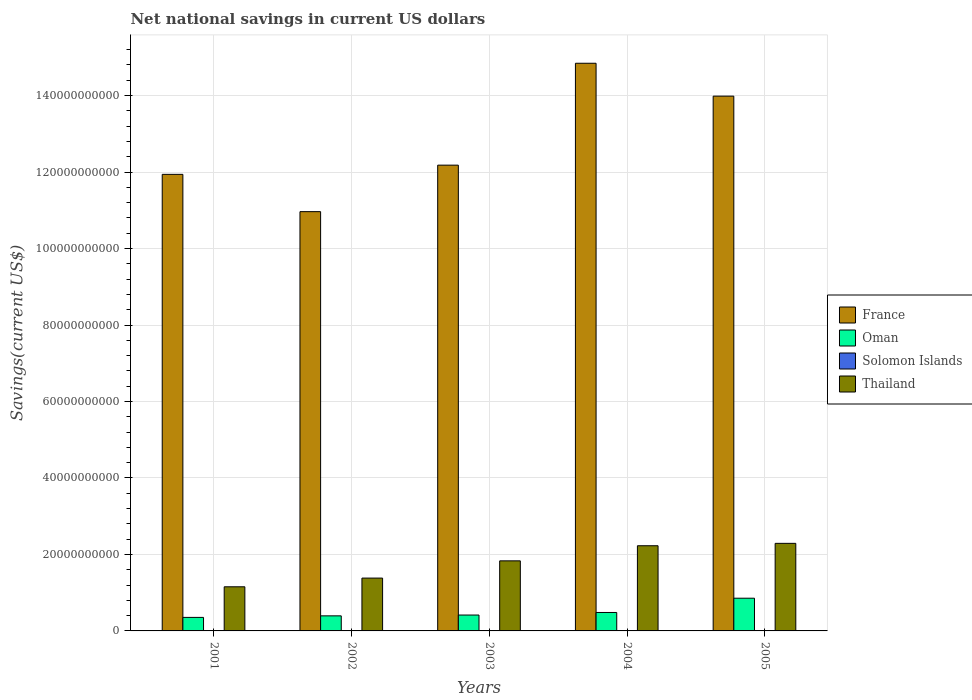How many groups of bars are there?
Make the answer very short. 5. How many bars are there on the 2nd tick from the left?
Give a very brief answer. 3. What is the net national savings in Thailand in 2002?
Ensure brevity in your answer.  1.38e+1. Across all years, what is the maximum net national savings in France?
Provide a succinct answer. 1.48e+11. What is the total net national savings in Oman in the graph?
Provide a short and direct response. 2.50e+1. What is the difference between the net national savings in France in 2003 and that in 2005?
Ensure brevity in your answer.  -1.80e+1. What is the difference between the net national savings in France in 2003 and the net national savings in Solomon Islands in 2001?
Provide a short and direct response. 1.22e+11. What is the average net national savings in Solomon Islands per year?
Ensure brevity in your answer.  2.64e+06. In the year 2003, what is the difference between the net national savings in Thailand and net national savings in Oman?
Offer a very short reply. 1.42e+1. What is the ratio of the net national savings in France in 2003 to that in 2005?
Keep it short and to the point. 0.87. Is the net national savings in Oman in 2003 less than that in 2004?
Make the answer very short. Yes. Is the difference between the net national savings in Thailand in 2002 and 2005 greater than the difference between the net national savings in Oman in 2002 and 2005?
Offer a terse response. No. What is the difference between the highest and the second highest net national savings in Oman?
Give a very brief answer. 3.73e+09. What is the difference between the highest and the lowest net national savings in France?
Provide a succinct answer. 3.88e+1. In how many years, is the net national savings in Solomon Islands greater than the average net national savings in Solomon Islands taken over all years?
Keep it short and to the point. 1. Is it the case that in every year, the sum of the net national savings in Thailand and net national savings in France is greater than the sum of net national savings in Oman and net national savings in Solomon Islands?
Keep it short and to the point. Yes. Is it the case that in every year, the sum of the net national savings in Oman and net national savings in Thailand is greater than the net national savings in France?
Ensure brevity in your answer.  No. How many bars are there?
Give a very brief answer. 16. Are all the bars in the graph horizontal?
Make the answer very short. No. How many years are there in the graph?
Offer a terse response. 5. What is the difference between two consecutive major ticks on the Y-axis?
Offer a terse response. 2.00e+1. Are the values on the major ticks of Y-axis written in scientific E-notation?
Your response must be concise. No. Does the graph contain any zero values?
Your response must be concise. Yes. Does the graph contain grids?
Keep it short and to the point. Yes. How are the legend labels stacked?
Your answer should be very brief. Vertical. What is the title of the graph?
Provide a succinct answer. Net national savings in current US dollars. Does "Vanuatu" appear as one of the legend labels in the graph?
Your response must be concise. No. What is the label or title of the X-axis?
Make the answer very short. Years. What is the label or title of the Y-axis?
Your answer should be very brief. Savings(current US$). What is the Savings(current US$) in France in 2001?
Ensure brevity in your answer.  1.19e+11. What is the Savings(current US$) of Oman in 2001?
Your answer should be very brief. 3.54e+09. What is the Savings(current US$) in Thailand in 2001?
Provide a succinct answer. 1.15e+1. What is the Savings(current US$) in France in 2002?
Give a very brief answer. 1.10e+11. What is the Savings(current US$) of Oman in 2002?
Your answer should be compact. 3.94e+09. What is the Savings(current US$) of Solomon Islands in 2002?
Give a very brief answer. 0. What is the Savings(current US$) in Thailand in 2002?
Ensure brevity in your answer.  1.38e+1. What is the Savings(current US$) of France in 2003?
Offer a terse response. 1.22e+11. What is the Savings(current US$) in Oman in 2003?
Offer a very short reply. 4.15e+09. What is the Savings(current US$) of Solomon Islands in 2003?
Provide a short and direct response. 1.32e+07. What is the Savings(current US$) in Thailand in 2003?
Your answer should be very brief. 1.83e+1. What is the Savings(current US$) in France in 2004?
Your answer should be compact. 1.48e+11. What is the Savings(current US$) in Oman in 2004?
Ensure brevity in your answer.  4.82e+09. What is the Savings(current US$) in Solomon Islands in 2004?
Ensure brevity in your answer.  0. What is the Savings(current US$) of Thailand in 2004?
Ensure brevity in your answer.  2.23e+1. What is the Savings(current US$) of France in 2005?
Provide a short and direct response. 1.40e+11. What is the Savings(current US$) of Oman in 2005?
Keep it short and to the point. 8.55e+09. What is the Savings(current US$) in Solomon Islands in 2005?
Your answer should be very brief. 0. What is the Savings(current US$) of Thailand in 2005?
Give a very brief answer. 2.29e+1. Across all years, what is the maximum Savings(current US$) of France?
Your response must be concise. 1.48e+11. Across all years, what is the maximum Savings(current US$) in Oman?
Your answer should be compact. 8.55e+09. Across all years, what is the maximum Savings(current US$) in Solomon Islands?
Give a very brief answer. 1.32e+07. Across all years, what is the maximum Savings(current US$) in Thailand?
Make the answer very short. 2.29e+1. Across all years, what is the minimum Savings(current US$) of France?
Offer a very short reply. 1.10e+11. Across all years, what is the minimum Savings(current US$) of Oman?
Keep it short and to the point. 3.54e+09. Across all years, what is the minimum Savings(current US$) of Thailand?
Your response must be concise. 1.15e+1. What is the total Savings(current US$) of France in the graph?
Your answer should be very brief. 6.39e+11. What is the total Savings(current US$) in Oman in the graph?
Your answer should be very brief. 2.50e+1. What is the total Savings(current US$) of Solomon Islands in the graph?
Your answer should be very brief. 1.32e+07. What is the total Savings(current US$) in Thailand in the graph?
Provide a short and direct response. 8.89e+1. What is the difference between the Savings(current US$) in France in 2001 and that in 2002?
Your answer should be very brief. 9.76e+09. What is the difference between the Savings(current US$) of Oman in 2001 and that in 2002?
Keep it short and to the point. -4.06e+08. What is the difference between the Savings(current US$) in Thailand in 2001 and that in 2002?
Offer a very short reply. -2.28e+09. What is the difference between the Savings(current US$) in France in 2001 and that in 2003?
Offer a very short reply. -2.41e+09. What is the difference between the Savings(current US$) of Oman in 2001 and that in 2003?
Give a very brief answer. -6.16e+08. What is the difference between the Savings(current US$) in Thailand in 2001 and that in 2003?
Your answer should be very brief. -6.78e+09. What is the difference between the Savings(current US$) of France in 2001 and that in 2004?
Your response must be concise. -2.91e+1. What is the difference between the Savings(current US$) of Oman in 2001 and that in 2004?
Give a very brief answer. -1.29e+09. What is the difference between the Savings(current US$) in Thailand in 2001 and that in 2004?
Give a very brief answer. -1.07e+1. What is the difference between the Savings(current US$) of France in 2001 and that in 2005?
Make the answer very short. -2.05e+1. What is the difference between the Savings(current US$) in Oman in 2001 and that in 2005?
Keep it short and to the point. -5.02e+09. What is the difference between the Savings(current US$) of Thailand in 2001 and that in 2005?
Offer a terse response. -1.14e+1. What is the difference between the Savings(current US$) of France in 2002 and that in 2003?
Your response must be concise. -1.22e+1. What is the difference between the Savings(current US$) in Oman in 2002 and that in 2003?
Your answer should be compact. -2.10e+08. What is the difference between the Savings(current US$) of Thailand in 2002 and that in 2003?
Provide a succinct answer. -4.50e+09. What is the difference between the Savings(current US$) in France in 2002 and that in 2004?
Offer a very short reply. -3.88e+1. What is the difference between the Savings(current US$) in Oman in 2002 and that in 2004?
Offer a very short reply. -8.83e+08. What is the difference between the Savings(current US$) in Thailand in 2002 and that in 2004?
Give a very brief answer. -8.46e+09. What is the difference between the Savings(current US$) of France in 2002 and that in 2005?
Give a very brief answer. -3.02e+1. What is the difference between the Savings(current US$) in Oman in 2002 and that in 2005?
Make the answer very short. -4.61e+09. What is the difference between the Savings(current US$) in Thailand in 2002 and that in 2005?
Give a very brief answer. -9.08e+09. What is the difference between the Savings(current US$) of France in 2003 and that in 2004?
Your answer should be very brief. -2.66e+1. What is the difference between the Savings(current US$) in Oman in 2003 and that in 2004?
Offer a terse response. -6.73e+08. What is the difference between the Savings(current US$) in Thailand in 2003 and that in 2004?
Provide a short and direct response. -3.95e+09. What is the difference between the Savings(current US$) of France in 2003 and that in 2005?
Give a very brief answer. -1.80e+1. What is the difference between the Savings(current US$) in Oman in 2003 and that in 2005?
Offer a very short reply. -4.40e+09. What is the difference between the Savings(current US$) of Thailand in 2003 and that in 2005?
Your answer should be very brief. -4.58e+09. What is the difference between the Savings(current US$) of France in 2004 and that in 2005?
Your answer should be compact. 8.60e+09. What is the difference between the Savings(current US$) in Oman in 2004 and that in 2005?
Your answer should be compact. -3.73e+09. What is the difference between the Savings(current US$) in Thailand in 2004 and that in 2005?
Offer a very short reply. -6.24e+08. What is the difference between the Savings(current US$) in France in 2001 and the Savings(current US$) in Oman in 2002?
Provide a short and direct response. 1.15e+11. What is the difference between the Savings(current US$) in France in 2001 and the Savings(current US$) in Thailand in 2002?
Give a very brief answer. 1.06e+11. What is the difference between the Savings(current US$) of Oman in 2001 and the Savings(current US$) of Thailand in 2002?
Ensure brevity in your answer.  -1.03e+1. What is the difference between the Savings(current US$) of France in 2001 and the Savings(current US$) of Oman in 2003?
Your answer should be very brief. 1.15e+11. What is the difference between the Savings(current US$) in France in 2001 and the Savings(current US$) in Solomon Islands in 2003?
Offer a very short reply. 1.19e+11. What is the difference between the Savings(current US$) of France in 2001 and the Savings(current US$) of Thailand in 2003?
Keep it short and to the point. 1.01e+11. What is the difference between the Savings(current US$) in Oman in 2001 and the Savings(current US$) in Solomon Islands in 2003?
Your answer should be very brief. 3.52e+09. What is the difference between the Savings(current US$) in Oman in 2001 and the Savings(current US$) in Thailand in 2003?
Provide a succinct answer. -1.48e+1. What is the difference between the Savings(current US$) in France in 2001 and the Savings(current US$) in Oman in 2004?
Offer a terse response. 1.15e+11. What is the difference between the Savings(current US$) of France in 2001 and the Savings(current US$) of Thailand in 2004?
Provide a succinct answer. 9.71e+1. What is the difference between the Savings(current US$) of Oman in 2001 and the Savings(current US$) of Thailand in 2004?
Your answer should be compact. -1.87e+1. What is the difference between the Savings(current US$) of France in 2001 and the Savings(current US$) of Oman in 2005?
Give a very brief answer. 1.11e+11. What is the difference between the Savings(current US$) in France in 2001 and the Savings(current US$) in Thailand in 2005?
Your answer should be very brief. 9.65e+1. What is the difference between the Savings(current US$) in Oman in 2001 and the Savings(current US$) in Thailand in 2005?
Your response must be concise. -1.94e+1. What is the difference between the Savings(current US$) of France in 2002 and the Savings(current US$) of Oman in 2003?
Your response must be concise. 1.05e+11. What is the difference between the Savings(current US$) of France in 2002 and the Savings(current US$) of Solomon Islands in 2003?
Keep it short and to the point. 1.10e+11. What is the difference between the Savings(current US$) of France in 2002 and the Savings(current US$) of Thailand in 2003?
Offer a terse response. 9.13e+1. What is the difference between the Savings(current US$) in Oman in 2002 and the Savings(current US$) in Solomon Islands in 2003?
Offer a terse response. 3.93e+09. What is the difference between the Savings(current US$) in Oman in 2002 and the Savings(current US$) in Thailand in 2003?
Offer a very short reply. -1.44e+1. What is the difference between the Savings(current US$) in France in 2002 and the Savings(current US$) in Oman in 2004?
Offer a terse response. 1.05e+11. What is the difference between the Savings(current US$) in France in 2002 and the Savings(current US$) in Thailand in 2004?
Your answer should be compact. 8.74e+1. What is the difference between the Savings(current US$) in Oman in 2002 and the Savings(current US$) in Thailand in 2004?
Provide a short and direct response. -1.83e+1. What is the difference between the Savings(current US$) in France in 2002 and the Savings(current US$) in Oman in 2005?
Your answer should be compact. 1.01e+11. What is the difference between the Savings(current US$) in France in 2002 and the Savings(current US$) in Thailand in 2005?
Ensure brevity in your answer.  8.67e+1. What is the difference between the Savings(current US$) of Oman in 2002 and the Savings(current US$) of Thailand in 2005?
Your response must be concise. -1.90e+1. What is the difference between the Savings(current US$) of France in 2003 and the Savings(current US$) of Oman in 2004?
Offer a very short reply. 1.17e+11. What is the difference between the Savings(current US$) of France in 2003 and the Savings(current US$) of Thailand in 2004?
Provide a short and direct response. 9.95e+1. What is the difference between the Savings(current US$) in Oman in 2003 and the Savings(current US$) in Thailand in 2004?
Your answer should be compact. -1.81e+1. What is the difference between the Savings(current US$) of Solomon Islands in 2003 and the Savings(current US$) of Thailand in 2004?
Your answer should be very brief. -2.23e+1. What is the difference between the Savings(current US$) of France in 2003 and the Savings(current US$) of Oman in 2005?
Provide a succinct answer. 1.13e+11. What is the difference between the Savings(current US$) of France in 2003 and the Savings(current US$) of Thailand in 2005?
Provide a succinct answer. 9.89e+1. What is the difference between the Savings(current US$) in Oman in 2003 and the Savings(current US$) in Thailand in 2005?
Give a very brief answer. -1.87e+1. What is the difference between the Savings(current US$) in Solomon Islands in 2003 and the Savings(current US$) in Thailand in 2005?
Your answer should be very brief. -2.29e+1. What is the difference between the Savings(current US$) of France in 2004 and the Savings(current US$) of Oman in 2005?
Your answer should be very brief. 1.40e+11. What is the difference between the Savings(current US$) in France in 2004 and the Savings(current US$) in Thailand in 2005?
Provide a short and direct response. 1.26e+11. What is the difference between the Savings(current US$) of Oman in 2004 and the Savings(current US$) of Thailand in 2005?
Keep it short and to the point. -1.81e+1. What is the average Savings(current US$) of France per year?
Offer a terse response. 1.28e+11. What is the average Savings(current US$) in Oman per year?
Your answer should be compact. 5.00e+09. What is the average Savings(current US$) in Solomon Islands per year?
Provide a short and direct response. 2.64e+06. What is the average Savings(current US$) in Thailand per year?
Keep it short and to the point. 1.78e+1. In the year 2001, what is the difference between the Savings(current US$) of France and Savings(current US$) of Oman?
Your answer should be compact. 1.16e+11. In the year 2001, what is the difference between the Savings(current US$) of France and Savings(current US$) of Thailand?
Ensure brevity in your answer.  1.08e+11. In the year 2001, what is the difference between the Savings(current US$) of Oman and Savings(current US$) of Thailand?
Provide a succinct answer. -8.01e+09. In the year 2002, what is the difference between the Savings(current US$) of France and Savings(current US$) of Oman?
Your answer should be compact. 1.06e+11. In the year 2002, what is the difference between the Savings(current US$) in France and Savings(current US$) in Thailand?
Provide a succinct answer. 9.58e+1. In the year 2002, what is the difference between the Savings(current US$) of Oman and Savings(current US$) of Thailand?
Provide a short and direct response. -9.88e+09. In the year 2003, what is the difference between the Savings(current US$) of France and Savings(current US$) of Oman?
Offer a very short reply. 1.18e+11. In the year 2003, what is the difference between the Savings(current US$) of France and Savings(current US$) of Solomon Islands?
Your answer should be compact. 1.22e+11. In the year 2003, what is the difference between the Savings(current US$) in France and Savings(current US$) in Thailand?
Make the answer very short. 1.03e+11. In the year 2003, what is the difference between the Savings(current US$) in Oman and Savings(current US$) in Solomon Islands?
Provide a short and direct response. 4.14e+09. In the year 2003, what is the difference between the Savings(current US$) in Oman and Savings(current US$) in Thailand?
Offer a terse response. -1.42e+1. In the year 2003, what is the difference between the Savings(current US$) in Solomon Islands and Savings(current US$) in Thailand?
Your answer should be compact. -1.83e+1. In the year 2004, what is the difference between the Savings(current US$) of France and Savings(current US$) of Oman?
Give a very brief answer. 1.44e+11. In the year 2004, what is the difference between the Savings(current US$) of France and Savings(current US$) of Thailand?
Your answer should be very brief. 1.26e+11. In the year 2004, what is the difference between the Savings(current US$) in Oman and Savings(current US$) in Thailand?
Your answer should be compact. -1.75e+1. In the year 2005, what is the difference between the Savings(current US$) of France and Savings(current US$) of Oman?
Offer a very short reply. 1.31e+11. In the year 2005, what is the difference between the Savings(current US$) of France and Savings(current US$) of Thailand?
Keep it short and to the point. 1.17e+11. In the year 2005, what is the difference between the Savings(current US$) of Oman and Savings(current US$) of Thailand?
Provide a succinct answer. -1.43e+1. What is the ratio of the Savings(current US$) in France in 2001 to that in 2002?
Your response must be concise. 1.09. What is the ratio of the Savings(current US$) in Oman in 2001 to that in 2002?
Offer a terse response. 0.9. What is the ratio of the Savings(current US$) in Thailand in 2001 to that in 2002?
Offer a terse response. 0.84. What is the ratio of the Savings(current US$) in France in 2001 to that in 2003?
Your answer should be very brief. 0.98. What is the ratio of the Savings(current US$) in Oman in 2001 to that in 2003?
Your response must be concise. 0.85. What is the ratio of the Savings(current US$) of Thailand in 2001 to that in 2003?
Offer a very short reply. 0.63. What is the ratio of the Savings(current US$) in France in 2001 to that in 2004?
Ensure brevity in your answer.  0.8. What is the ratio of the Savings(current US$) of Oman in 2001 to that in 2004?
Your answer should be compact. 0.73. What is the ratio of the Savings(current US$) of Thailand in 2001 to that in 2004?
Make the answer very short. 0.52. What is the ratio of the Savings(current US$) of France in 2001 to that in 2005?
Your answer should be compact. 0.85. What is the ratio of the Savings(current US$) of Oman in 2001 to that in 2005?
Provide a short and direct response. 0.41. What is the ratio of the Savings(current US$) of Thailand in 2001 to that in 2005?
Offer a very short reply. 0.5. What is the ratio of the Savings(current US$) of France in 2002 to that in 2003?
Your answer should be compact. 0.9. What is the ratio of the Savings(current US$) in Oman in 2002 to that in 2003?
Your response must be concise. 0.95. What is the ratio of the Savings(current US$) of Thailand in 2002 to that in 2003?
Provide a succinct answer. 0.75. What is the ratio of the Savings(current US$) of France in 2002 to that in 2004?
Your response must be concise. 0.74. What is the ratio of the Savings(current US$) of Oman in 2002 to that in 2004?
Offer a very short reply. 0.82. What is the ratio of the Savings(current US$) in Thailand in 2002 to that in 2004?
Ensure brevity in your answer.  0.62. What is the ratio of the Savings(current US$) of France in 2002 to that in 2005?
Your answer should be compact. 0.78. What is the ratio of the Savings(current US$) of Oman in 2002 to that in 2005?
Make the answer very short. 0.46. What is the ratio of the Savings(current US$) of Thailand in 2002 to that in 2005?
Offer a very short reply. 0.6. What is the ratio of the Savings(current US$) of France in 2003 to that in 2004?
Your answer should be very brief. 0.82. What is the ratio of the Savings(current US$) in Oman in 2003 to that in 2004?
Keep it short and to the point. 0.86. What is the ratio of the Savings(current US$) in Thailand in 2003 to that in 2004?
Keep it short and to the point. 0.82. What is the ratio of the Savings(current US$) of France in 2003 to that in 2005?
Make the answer very short. 0.87. What is the ratio of the Savings(current US$) in Oman in 2003 to that in 2005?
Provide a succinct answer. 0.49. What is the ratio of the Savings(current US$) of Thailand in 2003 to that in 2005?
Keep it short and to the point. 0.8. What is the ratio of the Savings(current US$) of France in 2004 to that in 2005?
Offer a terse response. 1.06. What is the ratio of the Savings(current US$) of Oman in 2004 to that in 2005?
Provide a short and direct response. 0.56. What is the ratio of the Savings(current US$) in Thailand in 2004 to that in 2005?
Provide a short and direct response. 0.97. What is the difference between the highest and the second highest Savings(current US$) in France?
Keep it short and to the point. 8.60e+09. What is the difference between the highest and the second highest Savings(current US$) in Oman?
Your answer should be very brief. 3.73e+09. What is the difference between the highest and the second highest Savings(current US$) of Thailand?
Your answer should be very brief. 6.24e+08. What is the difference between the highest and the lowest Savings(current US$) of France?
Your answer should be very brief. 3.88e+1. What is the difference between the highest and the lowest Savings(current US$) of Oman?
Ensure brevity in your answer.  5.02e+09. What is the difference between the highest and the lowest Savings(current US$) of Solomon Islands?
Offer a terse response. 1.32e+07. What is the difference between the highest and the lowest Savings(current US$) in Thailand?
Provide a short and direct response. 1.14e+1. 